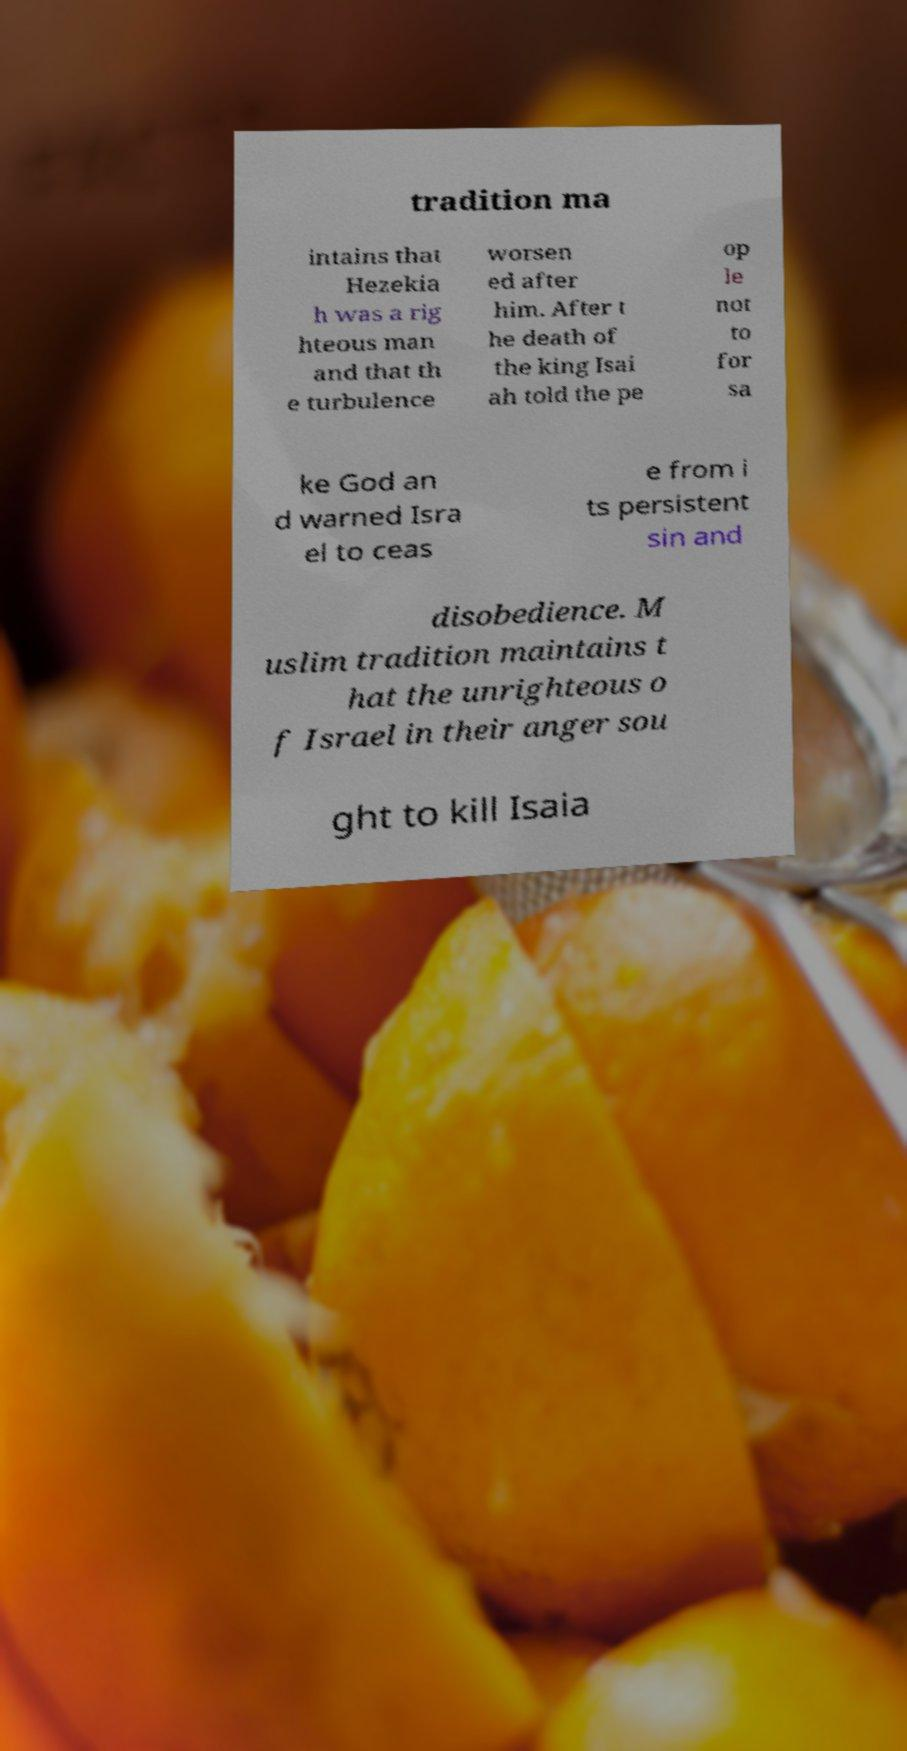Please read and relay the text visible in this image. What does it say? tradition ma intains that Hezekia h was a rig hteous man and that th e turbulence worsen ed after him. After t he death of the king Isai ah told the pe op le not to for sa ke God an d warned Isra el to ceas e from i ts persistent sin and disobedience. M uslim tradition maintains t hat the unrighteous o f Israel in their anger sou ght to kill Isaia 